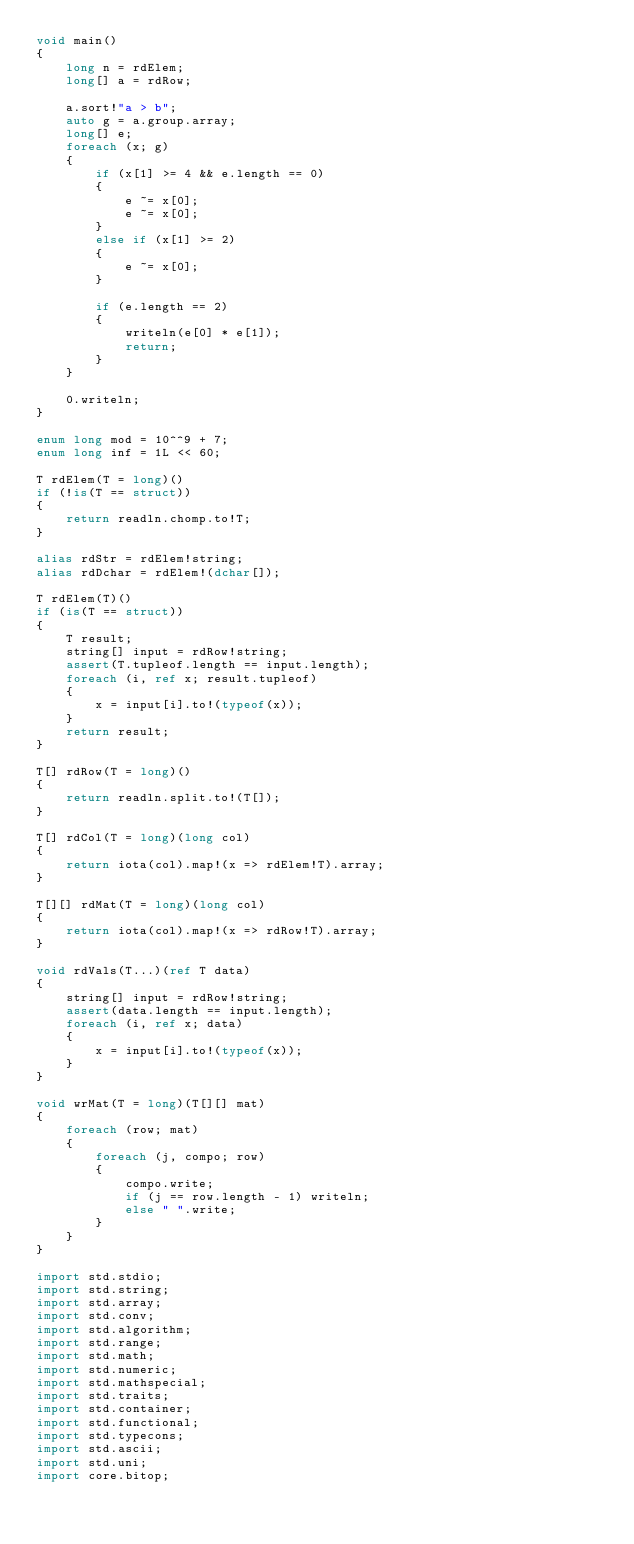<code> <loc_0><loc_0><loc_500><loc_500><_D_>void main()
{
    long n = rdElem;
    long[] a = rdRow;

    a.sort!"a > b";
    auto g = a.group.array;
    long[] e;
    foreach (x; g)
    {
        if (x[1] >= 4 && e.length == 0)
        {
            e ~= x[0];
            e ~= x[0];
        }
        else if (x[1] >= 2)
        {
            e ~= x[0];
        }

        if (e.length == 2)
        {
            writeln(e[0] * e[1]);
            return;
        }
    }

    0.writeln;
}

enum long mod = 10^^9 + 7;
enum long inf = 1L << 60;

T rdElem(T = long)()
if (!is(T == struct))
{
    return readln.chomp.to!T;
}

alias rdStr = rdElem!string;
alias rdDchar = rdElem!(dchar[]);

T rdElem(T)()
if (is(T == struct))
{
    T result;
    string[] input = rdRow!string;
    assert(T.tupleof.length == input.length);
    foreach (i, ref x; result.tupleof)
    {
        x = input[i].to!(typeof(x));
    }
    return result;
}

T[] rdRow(T = long)()
{
    return readln.split.to!(T[]);
}

T[] rdCol(T = long)(long col)
{
    return iota(col).map!(x => rdElem!T).array;
}

T[][] rdMat(T = long)(long col)
{
    return iota(col).map!(x => rdRow!T).array;
}

void rdVals(T...)(ref T data)
{
    string[] input = rdRow!string;
    assert(data.length == input.length);
    foreach (i, ref x; data)
    {
        x = input[i].to!(typeof(x));
    }
}

void wrMat(T = long)(T[][] mat)
{
    foreach (row; mat)
    {
        foreach (j, compo; row)
        {
            compo.write;
            if (j == row.length - 1) writeln;
            else " ".write;
        }
    }
}

import std.stdio;
import std.string;
import std.array;
import std.conv;
import std.algorithm;
import std.range;
import std.math;
import std.numeric;
import std.mathspecial;
import std.traits;
import std.container;
import std.functional;
import std.typecons;
import std.ascii;
import std.uni;
import core.bitop;</code> 